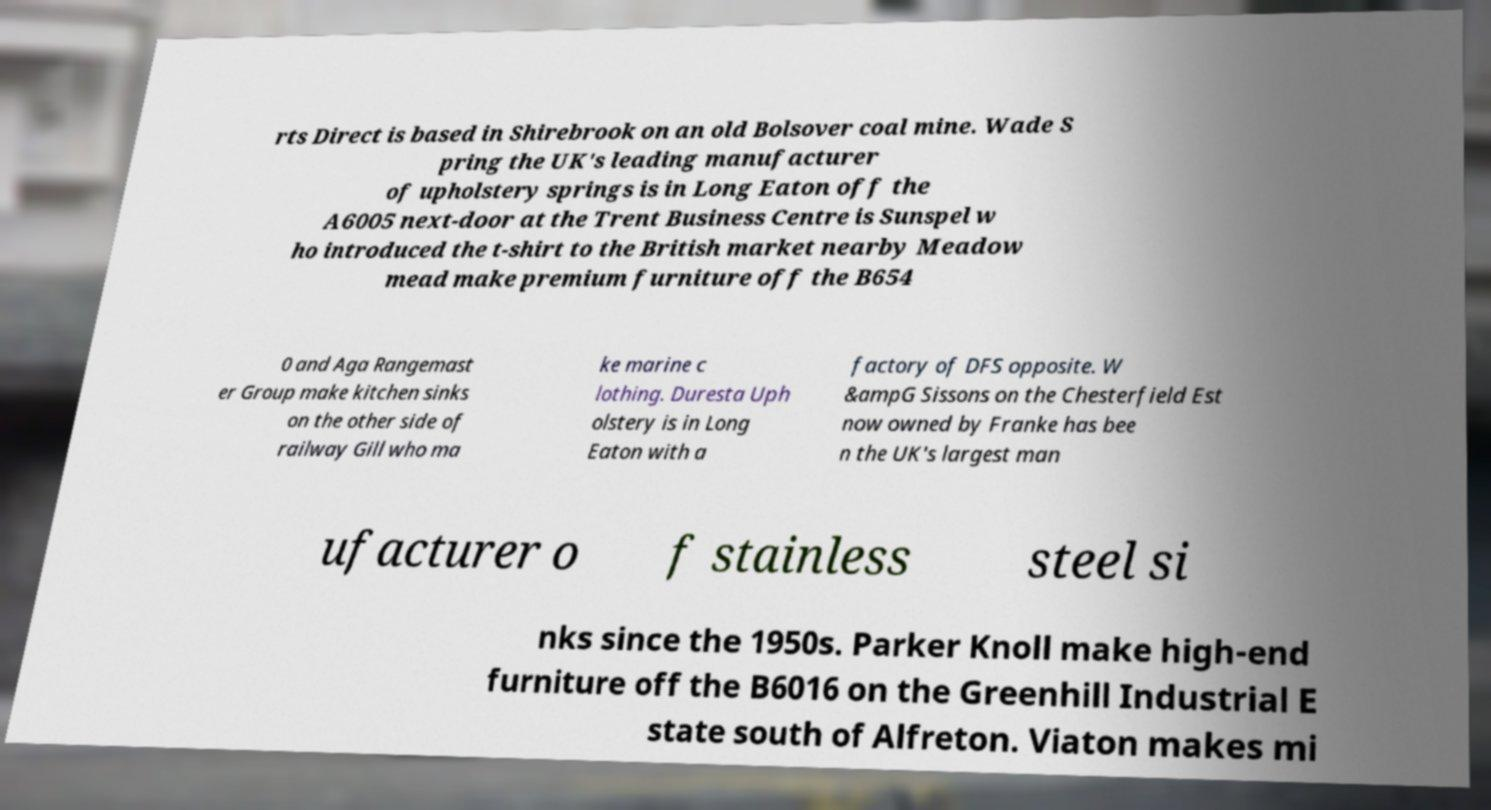Could you extract and type out the text from this image? rts Direct is based in Shirebrook on an old Bolsover coal mine. Wade S pring the UK's leading manufacturer of upholstery springs is in Long Eaton off the A6005 next-door at the Trent Business Centre is Sunspel w ho introduced the t-shirt to the British market nearby Meadow mead make premium furniture off the B654 0 and Aga Rangemast er Group make kitchen sinks on the other side of railway Gill who ma ke marine c lothing. Duresta Uph olstery is in Long Eaton with a factory of DFS opposite. W &ampG Sissons on the Chesterfield Est now owned by Franke has bee n the UK's largest man ufacturer o f stainless steel si nks since the 1950s. Parker Knoll make high-end furniture off the B6016 on the Greenhill Industrial E state south of Alfreton. Viaton makes mi 